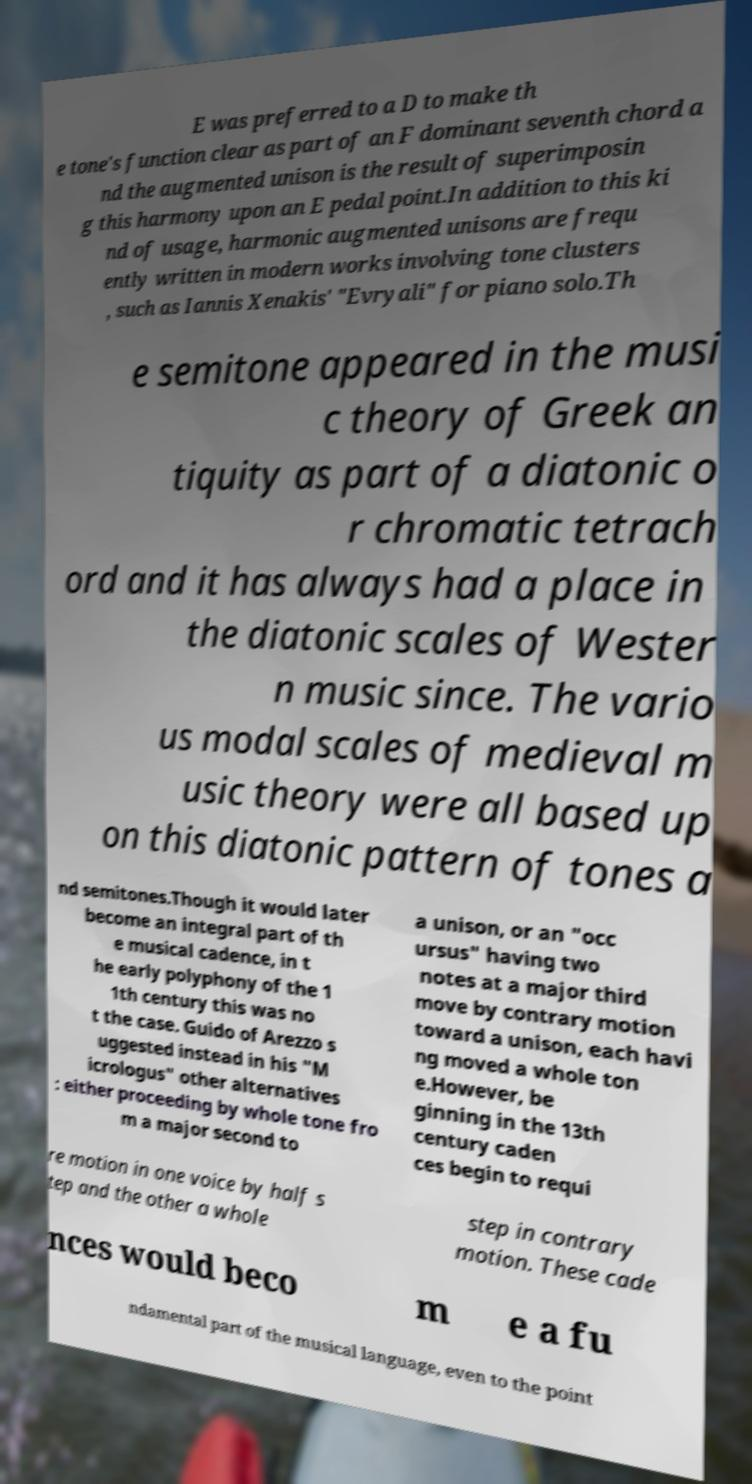Please read and relay the text visible in this image. What does it say? E was preferred to a D to make th e tone's function clear as part of an F dominant seventh chord a nd the augmented unison is the result of superimposin g this harmony upon an E pedal point.In addition to this ki nd of usage, harmonic augmented unisons are frequ ently written in modern works involving tone clusters , such as Iannis Xenakis' "Evryali" for piano solo.Th e semitone appeared in the musi c theory of Greek an tiquity as part of a diatonic o r chromatic tetrach ord and it has always had a place in the diatonic scales of Wester n music since. The vario us modal scales of medieval m usic theory were all based up on this diatonic pattern of tones a nd semitones.Though it would later become an integral part of th e musical cadence, in t he early polyphony of the 1 1th century this was no t the case. Guido of Arezzo s uggested instead in his "M icrologus" other alternatives : either proceeding by whole tone fro m a major second to a unison, or an "occ ursus" having two notes at a major third move by contrary motion toward a unison, each havi ng moved a whole ton e.However, be ginning in the 13th century caden ces begin to requi re motion in one voice by half s tep and the other a whole step in contrary motion. These cade nces would beco m e a fu ndamental part of the musical language, even to the point 